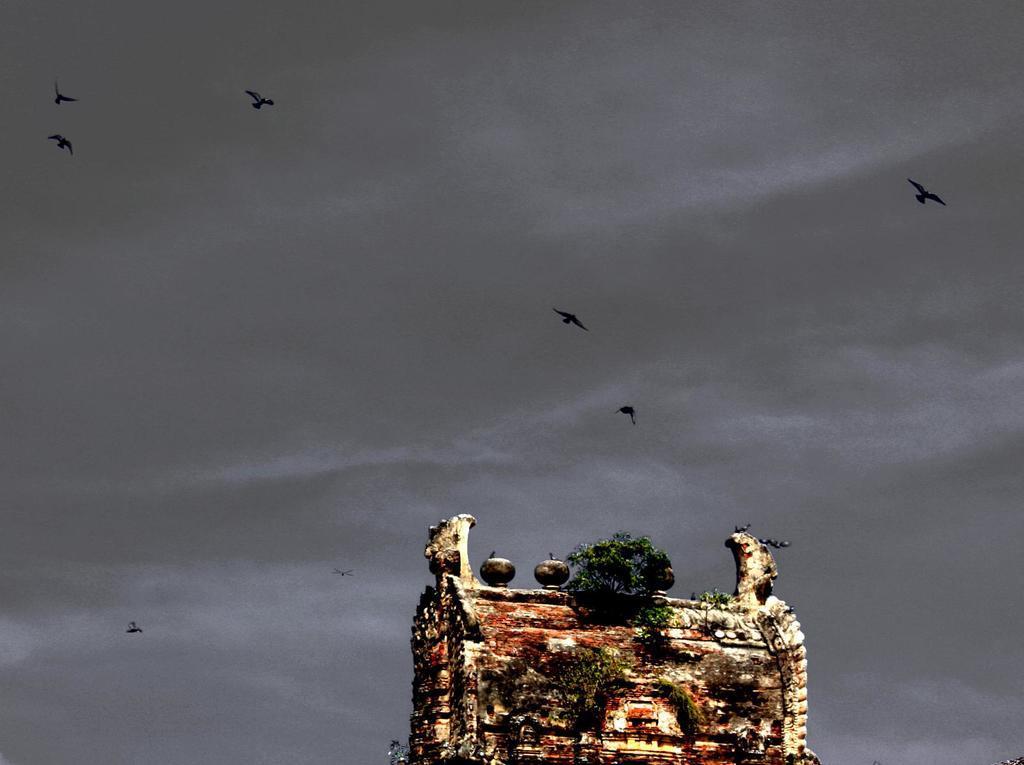Please provide a concise description of this image. This is a top of a building. On that there is a tree. In the background there is sky. Also there are birds flying. 